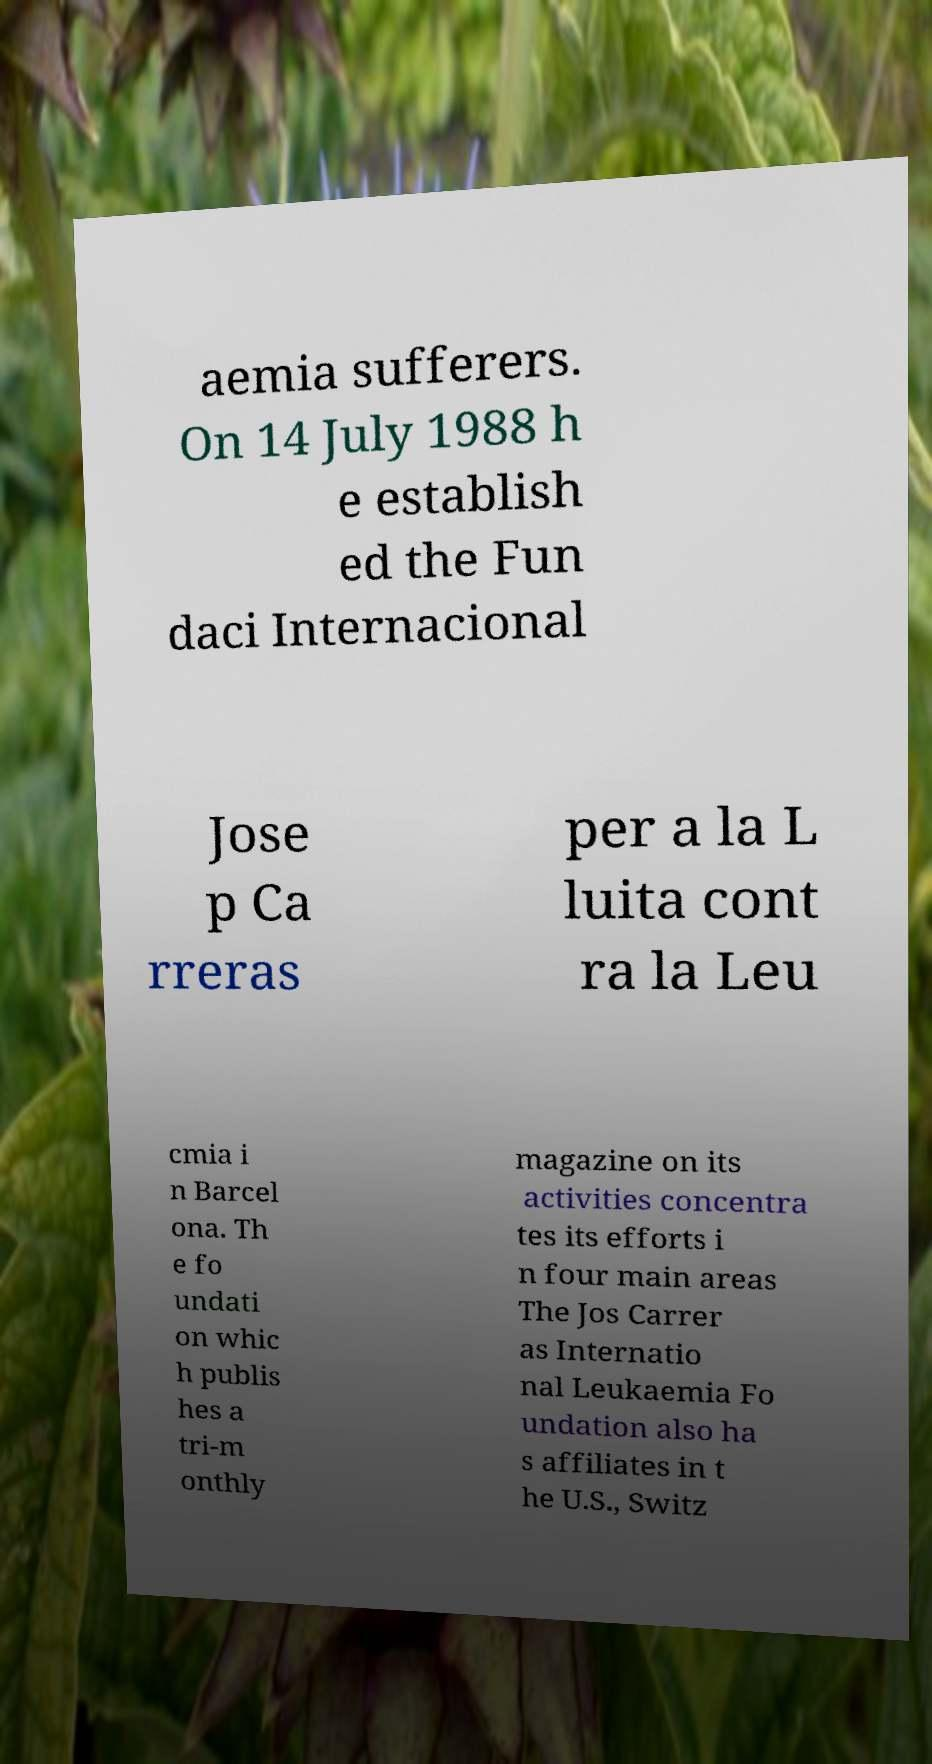Please read and relay the text visible in this image. What does it say? aemia sufferers. On 14 July 1988 h e establish ed the Fun daci Internacional Jose p Ca rreras per a la L luita cont ra la Leu cmia i n Barcel ona. Th e fo undati on whic h publis hes a tri-m onthly magazine on its activities concentra tes its efforts i n four main areas The Jos Carrer as Internatio nal Leukaemia Fo undation also ha s affiliates in t he U.S., Switz 